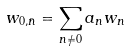<formula> <loc_0><loc_0><loc_500><loc_500>w _ { 0 , \bar { n } } = \sum _ { n \ne 0 } a _ { n } w _ { n }</formula> 